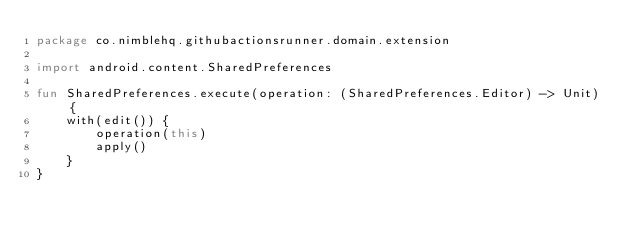<code> <loc_0><loc_0><loc_500><loc_500><_Kotlin_>package co.nimblehq.githubactionsrunner.domain.extension

import android.content.SharedPreferences

fun SharedPreferences.execute(operation: (SharedPreferences.Editor) -> Unit) {
    with(edit()) {
        operation(this)
        apply()
    }
}
</code> 